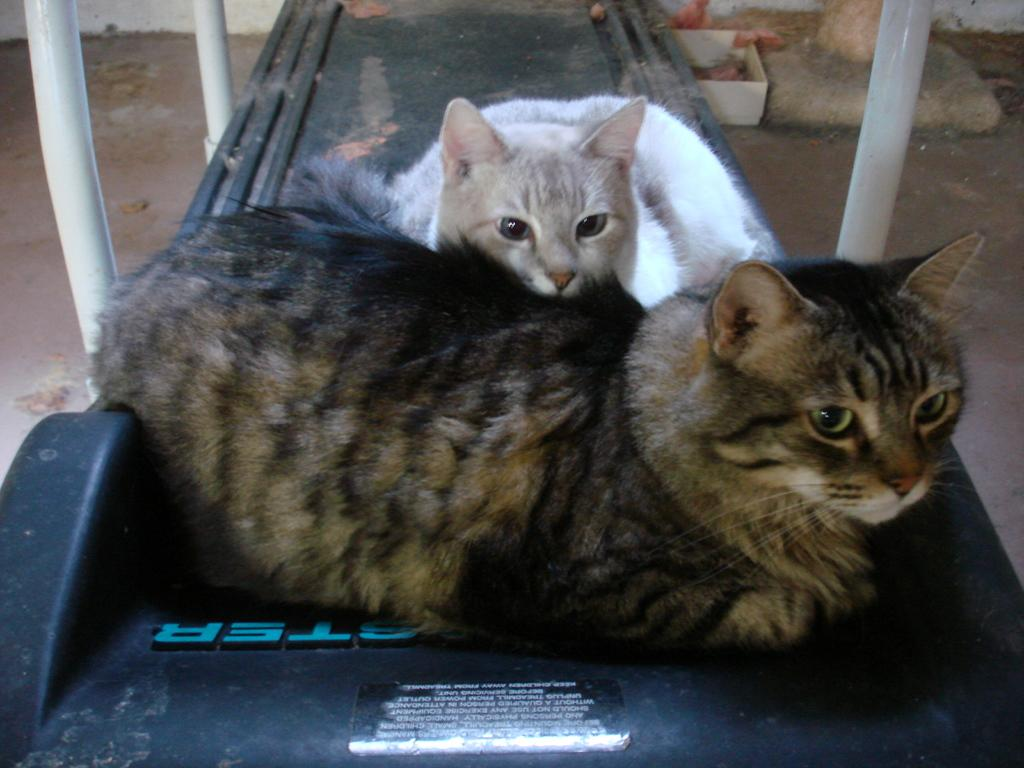What color is the main theme of the image? The image has a black color way. What type of animal can be seen sitting on the way? There is a black color cat and a white color cat sitting on the way. Is there any water visible in the image? No, there is no water present in the image. Are the cats blowing bubbles in the image? No, the cats are not blowing bubbles in the image. 